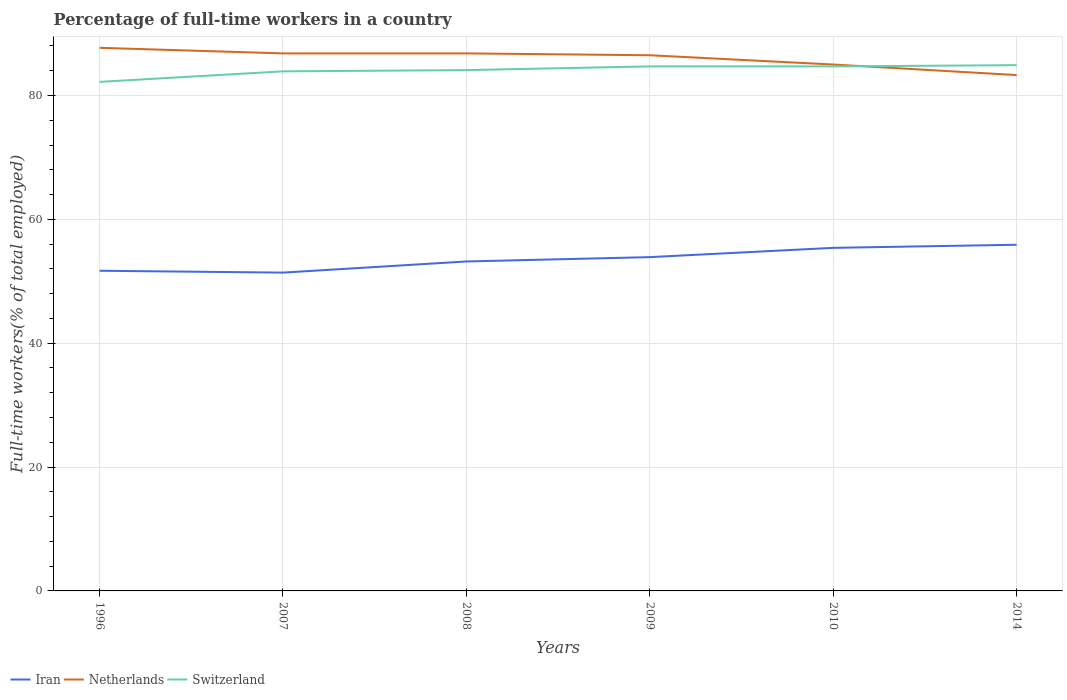How many different coloured lines are there?
Ensure brevity in your answer.  3. Does the line corresponding to Iran intersect with the line corresponding to Switzerland?
Give a very brief answer. No. Is the number of lines equal to the number of legend labels?
Give a very brief answer. Yes. Across all years, what is the maximum percentage of full-time workers in Netherlands?
Ensure brevity in your answer.  83.3. In which year was the percentage of full-time workers in Iran maximum?
Make the answer very short. 2007. What is the difference between the highest and the second highest percentage of full-time workers in Netherlands?
Offer a very short reply. 4.4. What is the difference between the highest and the lowest percentage of full-time workers in Switzerland?
Your response must be concise. 4. Is the percentage of full-time workers in Netherlands strictly greater than the percentage of full-time workers in Switzerland over the years?
Offer a terse response. No. How many lines are there?
Offer a very short reply. 3. How many years are there in the graph?
Offer a terse response. 6. What is the difference between two consecutive major ticks on the Y-axis?
Your response must be concise. 20. Does the graph contain grids?
Your answer should be very brief. Yes. How are the legend labels stacked?
Make the answer very short. Horizontal. What is the title of the graph?
Give a very brief answer. Percentage of full-time workers in a country. What is the label or title of the X-axis?
Ensure brevity in your answer.  Years. What is the label or title of the Y-axis?
Your response must be concise. Full-time workers(% of total employed). What is the Full-time workers(% of total employed) of Iran in 1996?
Your response must be concise. 51.7. What is the Full-time workers(% of total employed) in Netherlands in 1996?
Your answer should be compact. 87.7. What is the Full-time workers(% of total employed) of Switzerland in 1996?
Ensure brevity in your answer.  82.2. What is the Full-time workers(% of total employed) of Iran in 2007?
Your answer should be compact. 51.4. What is the Full-time workers(% of total employed) of Netherlands in 2007?
Your answer should be compact. 86.8. What is the Full-time workers(% of total employed) of Switzerland in 2007?
Provide a short and direct response. 83.9. What is the Full-time workers(% of total employed) in Iran in 2008?
Offer a very short reply. 53.2. What is the Full-time workers(% of total employed) in Netherlands in 2008?
Your response must be concise. 86.8. What is the Full-time workers(% of total employed) in Switzerland in 2008?
Offer a very short reply. 84.1. What is the Full-time workers(% of total employed) of Iran in 2009?
Offer a very short reply. 53.9. What is the Full-time workers(% of total employed) in Netherlands in 2009?
Keep it short and to the point. 86.5. What is the Full-time workers(% of total employed) in Switzerland in 2009?
Your response must be concise. 84.7. What is the Full-time workers(% of total employed) in Iran in 2010?
Provide a short and direct response. 55.4. What is the Full-time workers(% of total employed) in Netherlands in 2010?
Provide a succinct answer. 85. What is the Full-time workers(% of total employed) in Switzerland in 2010?
Provide a succinct answer. 84.7. What is the Full-time workers(% of total employed) of Iran in 2014?
Offer a very short reply. 55.9. What is the Full-time workers(% of total employed) of Netherlands in 2014?
Ensure brevity in your answer.  83.3. What is the Full-time workers(% of total employed) in Switzerland in 2014?
Give a very brief answer. 84.9. Across all years, what is the maximum Full-time workers(% of total employed) of Iran?
Make the answer very short. 55.9. Across all years, what is the maximum Full-time workers(% of total employed) in Netherlands?
Provide a succinct answer. 87.7. Across all years, what is the maximum Full-time workers(% of total employed) of Switzerland?
Your response must be concise. 84.9. Across all years, what is the minimum Full-time workers(% of total employed) in Iran?
Provide a succinct answer. 51.4. Across all years, what is the minimum Full-time workers(% of total employed) in Netherlands?
Ensure brevity in your answer.  83.3. Across all years, what is the minimum Full-time workers(% of total employed) of Switzerland?
Provide a short and direct response. 82.2. What is the total Full-time workers(% of total employed) of Iran in the graph?
Keep it short and to the point. 321.5. What is the total Full-time workers(% of total employed) in Netherlands in the graph?
Give a very brief answer. 516.1. What is the total Full-time workers(% of total employed) of Switzerland in the graph?
Provide a short and direct response. 504.5. What is the difference between the Full-time workers(% of total employed) in Iran in 1996 and that in 2007?
Offer a very short reply. 0.3. What is the difference between the Full-time workers(% of total employed) in Netherlands in 1996 and that in 2007?
Your response must be concise. 0.9. What is the difference between the Full-time workers(% of total employed) in Switzerland in 1996 and that in 2007?
Provide a succinct answer. -1.7. What is the difference between the Full-time workers(% of total employed) in Iran in 1996 and that in 2008?
Ensure brevity in your answer.  -1.5. What is the difference between the Full-time workers(% of total employed) in Switzerland in 1996 and that in 2008?
Your response must be concise. -1.9. What is the difference between the Full-time workers(% of total employed) of Iran in 1996 and that in 2009?
Ensure brevity in your answer.  -2.2. What is the difference between the Full-time workers(% of total employed) of Switzerland in 1996 and that in 2009?
Offer a very short reply. -2.5. What is the difference between the Full-time workers(% of total employed) in Netherlands in 1996 and that in 2010?
Provide a succinct answer. 2.7. What is the difference between the Full-time workers(% of total employed) in Iran in 1996 and that in 2014?
Your answer should be compact. -4.2. What is the difference between the Full-time workers(% of total employed) of Iran in 2007 and that in 2008?
Offer a terse response. -1.8. What is the difference between the Full-time workers(% of total employed) in Netherlands in 2007 and that in 2008?
Offer a very short reply. 0. What is the difference between the Full-time workers(% of total employed) in Switzerland in 2007 and that in 2008?
Your answer should be very brief. -0.2. What is the difference between the Full-time workers(% of total employed) of Netherlands in 2007 and that in 2009?
Offer a very short reply. 0.3. What is the difference between the Full-time workers(% of total employed) of Switzerland in 2007 and that in 2009?
Provide a succinct answer. -0.8. What is the difference between the Full-time workers(% of total employed) of Switzerland in 2007 and that in 2010?
Ensure brevity in your answer.  -0.8. What is the difference between the Full-time workers(% of total employed) in Iran in 2007 and that in 2014?
Provide a succinct answer. -4.5. What is the difference between the Full-time workers(% of total employed) in Netherlands in 2007 and that in 2014?
Your answer should be very brief. 3.5. What is the difference between the Full-time workers(% of total employed) of Iran in 2008 and that in 2009?
Your answer should be compact. -0.7. What is the difference between the Full-time workers(% of total employed) of Netherlands in 2008 and that in 2009?
Give a very brief answer. 0.3. What is the difference between the Full-time workers(% of total employed) in Switzerland in 2008 and that in 2009?
Offer a very short reply. -0.6. What is the difference between the Full-time workers(% of total employed) of Iran in 2008 and that in 2010?
Your answer should be very brief. -2.2. What is the difference between the Full-time workers(% of total employed) in Netherlands in 2008 and that in 2010?
Offer a very short reply. 1.8. What is the difference between the Full-time workers(% of total employed) in Iran in 2008 and that in 2014?
Make the answer very short. -2.7. What is the difference between the Full-time workers(% of total employed) of Switzerland in 2009 and that in 2010?
Give a very brief answer. 0. What is the difference between the Full-time workers(% of total employed) in Netherlands in 2009 and that in 2014?
Offer a very short reply. 3.2. What is the difference between the Full-time workers(% of total employed) in Switzerland in 2009 and that in 2014?
Your answer should be compact. -0.2. What is the difference between the Full-time workers(% of total employed) of Netherlands in 2010 and that in 2014?
Offer a very short reply. 1.7. What is the difference between the Full-time workers(% of total employed) in Iran in 1996 and the Full-time workers(% of total employed) in Netherlands in 2007?
Give a very brief answer. -35.1. What is the difference between the Full-time workers(% of total employed) in Iran in 1996 and the Full-time workers(% of total employed) in Switzerland in 2007?
Provide a short and direct response. -32.2. What is the difference between the Full-time workers(% of total employed) of Netherlands in 1996 and the Full-time workers(% of total employed) of Switzerland in 2007?
Make the answer very short. 3.8. What is the difference between the Full-time workers(% of total employed) in Iran in 1996 and the Full-time workers(% of total employed) in Netherlands in 2008?
Provide a succinct answer. -35.1. What is the difference between the Full-time workers(% of total employed) of Iran in 1996 and the Full-time workers(% of total employed) of Switzerland in 2008?
Offer a terse response. -32.4. What is the difference between the Full-time workers(% of total employed) of Netherlands in 1996 and the Full-time workers(% of total employed) of Switzerland in 2008?
Give a very brief answer. 3.6. What is the difference between the Full-time workers(% of total employed) of Iran in 1996 and the Full-time workers(% of total employed) of Netherlands in 2009?
Ensure brevity in your answer.  -34.8. What is the difference between the Full-time workers(% of total employed) of Iran in 1996 and the Full-time workers(% of total employed) of Switzerland in 2009?
Keep it short and to the point. -33. What is the difference between the Full-time workers(% of total employed) in Netherlands in 1996 and the Full-time workers(% of total employed) in Switzerland in 2009?
Offer a very short reply. 3. What is the difference between the Full-time workers(% of total employed) of Iran in 1996 and the Full-time workers(% of total employed) of Netherlands in 2010?
Ensure brevity in your answer.  -33.3. What is the difference between the Full-time workers(% of total employed) in Iran in 1996 and the Full-time workers(% of total employed) in Switzerland in 2010?
Provide a succinct answer. -33. What is the difference between the Full-time workers(% of total employed) of Iran in 1996 and the Full-time workers(% of total employed) of Netherlands in 2014?
Provide a short and direct response. -31.6. What is the difference between the Full-time workers(% of total employed) of Iran in 1996 and the Full-time workers(% of total employed) of Switzerland in 2014?
Your answer should be very brief. -33.2. What is the difference between the Full-time workers(% of total employed) in Iran in 2007 and the Full-time workers(% of total employed) in Netherlands in 2008?
Provide a succinct answer. -35.4. What is the difference between the Full-time workers(% of total employed) in Iran in 2007 and the Full-time workers(% of total employed) in Switzerland in 2008?
Offer a very short reply. -32.7. What is the difference between the Full-time workers(% of total employed) of Iran in 2007 and the Full-time workers(% of total employed) of Netherlands in 2009?
Give a very brief answer. -35.1. What is the difference between the Full-time workers(% of total employed) of Iran in 2007 and the Full-time workers(% of total employed) of Switzerland in 2009?
Make the answer very short. -33.3. What is the difference between the Full-time workers(% of total employed) of Iran in 2007 and the Full-time workers(% of total employed) of Netherlands in 2010?
Provide a short and direct response. -33.6. What is the difference between the Full-time workers(% of total employed) in Iran in 2007 and the Full-time workers(% of total employed) in Switzerland in 2010?
Offer a very short reply. -33.3. What is the difference between the Full-time workers(% of total employed) of Netherlands in 2007 and the Full-time workers(% of total employed) of Switzerland in 2010?
Provide a short and direct response. 2.1. What is the difference between the Full-time workers(% of total employed) of Iran in 2007 and the Full-time workers(% of total employed) of Netherlands in 2014?
Offer a terse response. -31.9. What is the difference between the Full-time workers(% of total employed) of Iran in 2007 and the Full-time workers(% of total employed) of Switzerland in 2014?
Your response must be concise. -33.5. What is the difference between the Full-time workers(% of total employed) in Iran in 2008 and the Full-time workers(% of total employed) in Netherlands in 2009?
Give a very brief answer. -33.3. What is the difference between the Full-time workers(% of total employed) of Iran in 2008 and the Full-time workers(% of total employed) of Switzerland in 2009?
Your answer should be compact. -31.5. What is the difference between the Full-time workers(% of total employed) in Netherlands in 2008 and the Full-time workers(% of total employed) in Switzerland in 2009?
Ensure brevity in your answer.  2.1. What is the difference between the Full-time workers(% of total employed) of Iran in 2008 and the Full-time workers(% of total employed) of Netherlands in 2010?
Offer a terse response. -31.8. What is the difference between the Full-time workers(% of total employed) in Iran in 2008 and the Full-time workers(% of total employed) in Switzerland in 2010?
Offer a terse response. -31.5. What is the difference between the Full-time workers(% of total employed) in Netherlands in 2008 and the Full-time workers(% of total employed) in Switzerland in 2010?
Offer a very short reply. 2.1. What is the difference between the Full-time workers(% of total employed) of Iran in 2008 and the Full-time workers(% of total employed) of Netherlands in 2014?
Give a very brief answer. -30.1. What is the difference between the Full-time workers(% of total employed) of Iran in 2008 and the Full-time workers(% of total employed) of Switzerland in 2014?
Make the answer very short. -31.7. What is the difference between the Full-time workers(% of total employed) of Iran in 2009 and the Full-time workers(% of total employed) of Netherlands in 2010?
Give a very brief answer. -31.1. What is the difference between the Full-time workers(% of total employed) in Iran in 2009 and the Full-time workers(% of total employed) in Switzerland in 2010?
Keep it short and to the point. -30.8. What is the difference between the Full-time workers(% of total employed) of Netherlands in 2009 and the Full-time workers(% of total employed) of Switzerland in 2010?
Provide a short and direct response. 1.8. What is the difference between the Full-time workers(% of total employed) of Iran in 2009 and the Full-time workers(% of total employed) of Netherlands in 2014?
Make the answer very short. -29.4. What is the difference between the Full-time workers(% of total employed) in Iran in 2009 and the Full-time workers(% of total employed) in Switzerland in 2014?
Keep it short and to the point. -31. What is the difference between the Full-time workers(% of total employed) of Netherlands in 2009 and the Full-time workers(% of total employed) of Switzerland in 2014?
Your response must be concise. 1.6. What is the difference between the Full-time workers(% of total employed) of Iran in 2010 and the Full-time workers(% of total employed) of Netherlands in 2014?
Your answer should be compact. -27.9. What is the difference between the Full-time workers(% of total employed) of Iran in 2010 and the Full-time workers(% of total employed) of Switzerland in 2014?
Provide a succinct answer. -29.5. What is the difference between the Full-time workers(% of total employed) in Netherlands in 2010 and the Full-time workers(% of total employed) in Switzerland in 2014?
Give a very brief answer. 0.1. What is the average Full-time workers(% of total employed) of Iran per year?
Your answer should be very brief. 53.58. What is the average Full-time workers(% of total employed) in Netherlands per year?
Give a very brief answer. 86.02. What is the average Full-time workers(% of total employed) in Switzerland per year?
Provide a short and direct response. 84.08. In the year 1996, what is the difference between the Full-time workers(% of total employed) of Iran and Full-time workers(% of total employed) of Netherlands?
Ensure brevity in your answer.  -36. In the year 1996, what is the difference between the Full-time workers(% of total employed) in Iran and Full-time workers(% of total employed) in Switzerland?
Offer a very short reply. -30.5. In the year 2007, what is the difference between the Full-time workers(% of total employed) in Iran and Full-time workers(% of total employed) in Netherlands?
Your response must be concise. -35.4. In the year 2007, what is the difference between the Full-time workers(% of total employed) in Iran and Full-time workers(% of total employed) in Switzerland?
Offer a terse response. -32.5. In the year 2007, what is the difference between the Full-time workers(% of total employed) of Netherlands and Full-time workers(% of total employed) of Switzerland?
Keep it short and to the point. 2.9. In the year 2008, what is the difference between the Full-time workers(% of total employed) of Iran and Full-time workers(% of total employed) of Netherlands?
Provide a short and direct response. -33.6. In the year 2008, what is the difference between the Full-time workers(% of total employed) in Iran and Full-time workers(% of total employed) in Switzerland?
Your answer should be compact. -30.9. In the year 2008, what is the difference between the Full-time workers(% of total employed) in Netherlands and Full-time workers(% of total employed) in Switzerland?
Offer a terse response. 2.7. In the year 2009, what is the difference between the Full-time workers(% of total employed) of Iran and Full-time workers(% of total employed) of Netherlands?
Offer a terse response. -32.6. In the year 2009, what is the difference between the Full-time workers(% of total employed) of Iran and Full-time workers(% of total employed) of Switzerland?
Provide a succinct answer. -30.8. In the year 2010, what is the difference between the Full-time workers(% of total employed) of Iran and Full-time workers(% of total employed) of Netherlands?
Give a very brief answer. -29.6. In the year 2010, what is the difference between the Full-time workers(% of total employed) in Iran and Full-time workers(% of total employed) in Switzerland?
Your response must be concise. -29.3. In the year 2014, what is the difference between the Full-time workers(% of total employed) of Iran and Full-time workers(% of total employed) of Netherlands?
Offer a very short reply. -27.4. In the year 2014, what is the difference between the Full-time workers(% of total employed) in Iran and Full-time workers(% of total employed) in Switzerland?
Make the answer very short. -29. What is the ratio of the Full-time workers(% of total employed) in Iran in 1996 to that in 2007?
Ensure brevity in your answer.  1.01. What is the ratio of the Full-time workers(% of total employed) of Netherlands in 1996 to that in 2007?
Provide a short and direct response. 1.01. What is the ratio of the Full-time workers(% of total employed) in Switzerland in 1996 to that in 2007?
Offer a very short reply. 0.98. What is the ratio of the Full-time workers(% of total employed) of Iran in 1996 to that in 2008?
Ensure brevity in your answer.  0.97. What is the ratio of the Full-time workers(% of total employed) of Netherlands in 1996 to that in 2008?
Make the answer very short. 1.01. What is the ratio of the Full-time workers(% of total employed) in Switzerland in 1996 to that in 2008?
Offer a terse response. 0.98. What is the ratio of the Full-time workers(% of total employed) in Iran in 1996 to that in 2009?
Offer a very short reply. 0.96. What is the ratio of the Full-time workers(% of total employed) of Netherlands in 1996 to that in 2009?
Provide a succinct answer. 1.01. What is the ratio of the Full-time workers(% of total employed) of Switzerland in 1996 to that in 2009?
Your response must be concise. 0.97. What is the ratio of the Full-time workers(% of total employed) in Iran in 1996 to that in 2010?
Offer a very short reply. 0.93. What is the ratio of the Full-time workers(% of total employed) in Netherlands in 1996 to that in 2010?
Provide a succinct answer. 1.03. What is the ratio of the Full-time workers(% of total employed) in Switzerland in 1996 to that in 2010?
Offer a very short reply. 0.97. What is the ratio of the Full-time workers(% of total employed) in Iran in 1996 to that in 2014?
Your answer should be very brief. 0.92. What is the ratio of the Full-time workers(% of total employed) of Netherlands in 1996 to that in 2014?
Provide a short and direct response. 1.05. What is the ratio of the Full-time workers(% of total employed) of Switzerland in 1996 to that in 2014?
Your answer should be compact. 0.97. What is the ratio of the Full-time workers(% of total employed) of Iran in 2007 to that in 2008?
Provide a succinct answer. 0.97. What is the ratio of the Full-time workers(% of total employed) in Switzerland in 2007 to that in 2008?
Give a very brief answer. 1. What is the ratio of the Full-time workers(% of total employed) of Iran in 2007 to that in 2009?
Offer a very short reply. 0.95. What is the ratio of the Full-time workers(% of total employed) of Switzerland in 2007 to that in 2009?
Provide a succinct answer. 0.99. What is the ratio of the Full-time workers(% of total employed) in Iran in 2007 to that in 2010?
Offer a very short reply. 0.93. What is the ratio of the Full-time workers(% of total employed) in Netherlands in 2007 to that in 2010?
Your response must be concise. 1.02. What is the ratio of the Full-time workers(% of total employed) of Switzerland in 2007 to that in 2010?
Your answer should be compact. 0.99. What is the ratio of the Full-time workers(% of total employed) in Iran in 2007 to that in 2014?
Keep it short and to the point. 0.92. What is the ratio of the Full-time workers(% of total employed) in Netherlands in 2007 to that in 2014?
Offer a terse response. 1.04. What is the ratio of the Full-time workers(% of total employed) of Switzerland in 2007 to that in 2014?
Provide a succinct answer. 0.99. What is the ratio of the Full-time workers(% of total employed) in Netherlands in 2008 to that in 2009?
Offer a very short reply. 1. What is the ratio of the Full-time workers(% of total employed) in Switzerland in 2008 to that in 2009?
Provide a succinct answer. 0.99. What is the ratio of the Full-time workers(% of total employed) of Iran in 2008 to that in 2010?
Provide a short and direct response. 0.96. What is the ratio of the Full-time workers(% of total employed) in Netherlands in 2008 to that in 2010?
Ensure brevity in your answer.  1.02. What is the ratio of the Full-time workers(% of total employed) of Switzerland in 2008 to that in 2010?
Your answer should be very brief. 0.99. What is the ratio of the Full-time workers(% of total employed) of Iran in 2008 to that in 2014?
Keep it short and to the point. 0.95. What is the ratio of the Full-time workers(% of total employed) of Netherlands in 2008 to that in 2014?
Provide a succinct answer. 1.04. What is the ratio of the Full-time workers(% of total employed) in Switzerland in 2008 to that in 2014?
Your answer should be very brief. 0.99. What is the ratio of the Full-time workers(% of total employed) in Iran in 2009 to that in 2010?
Make the answer very short. 0.97. What is the ratio of the Full-time workers(% of total employed) of Netherlands in 2009 to that in 2010?
Keep it short and to the point. 1.02. What is the ratio of the Full-time workers(% of total employed) of Switzerland in 2009 to that in 2010?
Provide a short and direct response. 1. What is the ratio of the Full-time workers(% of total employed) of Iran in 2009 to that in 2014?
Provide a succinct answer. 0.96. What is the ratio of the Full-time workers(% of total employed) of Netherlands in 2009 to that in 2014?
Provide a succinct answer. 1.04. What is the ratio of the Full-time workers(% of total employed) of Netherlands in 2010 to that in 2014?
Make the answer very short. 1.02. What is the ratio of the Full-time workers(% of total employed) of Switzerland in 2010 to that in 2014?
Your answer should be very brief. 1. What is the difference between the highest and the second highest Full-time workers(% of total employed) in Iran?
Provide a succinct answer. 0.5. What is the difference between the highest and the second highest Full-time workers(% of total employed) of Switzerland?
Give a very brief answer. 0.2. What is the difference between the highest and the lowest Full-time workers(% of total employed) of Netherlands?
Ensure brevity in your answer.  4.4. 